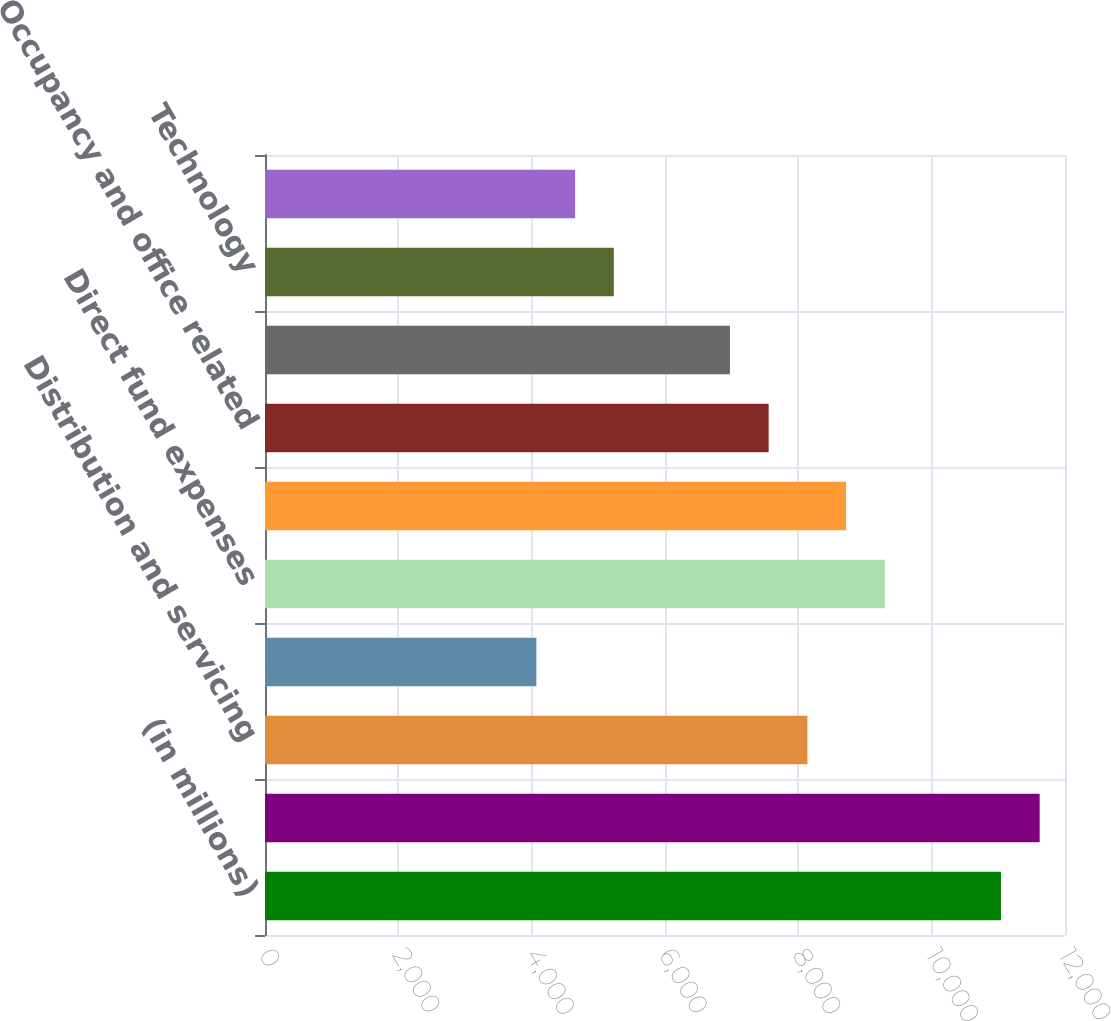<chart> <loc_0><loc_0><loc_500><loc_500><bar_chart><fcel>(in millions)<fcel>Employee compensation and<fcel>Distribution and servicing<fcel>Amortization of deferred sales<fcel>Direct fund expenses<fcel>Marketing and promotional<fcel>Occupancy and office related<fcel>Portfolio services<fcel>Technology<fcel>Professional services<nl><fcel>11039.3<fcel>11620<fcel>8135.8<fcel>4070.9<fcel>9297.2<fcel>8716.5<fcel>7555.1<fcel>6974.4<fcel>5232.3<fcel>4651.6<nl></chart> 